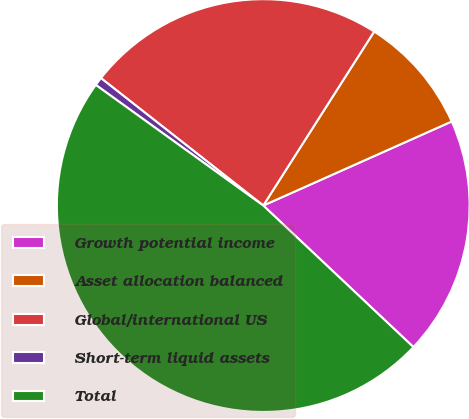Convert chart to OTSL. <chart><loc_0><loc_0><loc_500><loc_500><pie_chart><fcel>Growth potential income<fcel>Asset allocation balanced<fcel>Global/international US<fcel>Short-term liquid assets<fcel>Total<nl><fcel>18.71%<fcel>9.29%<fcel>23.44%<fcel>0.66%<fcel>47.91%<nl></chart> 